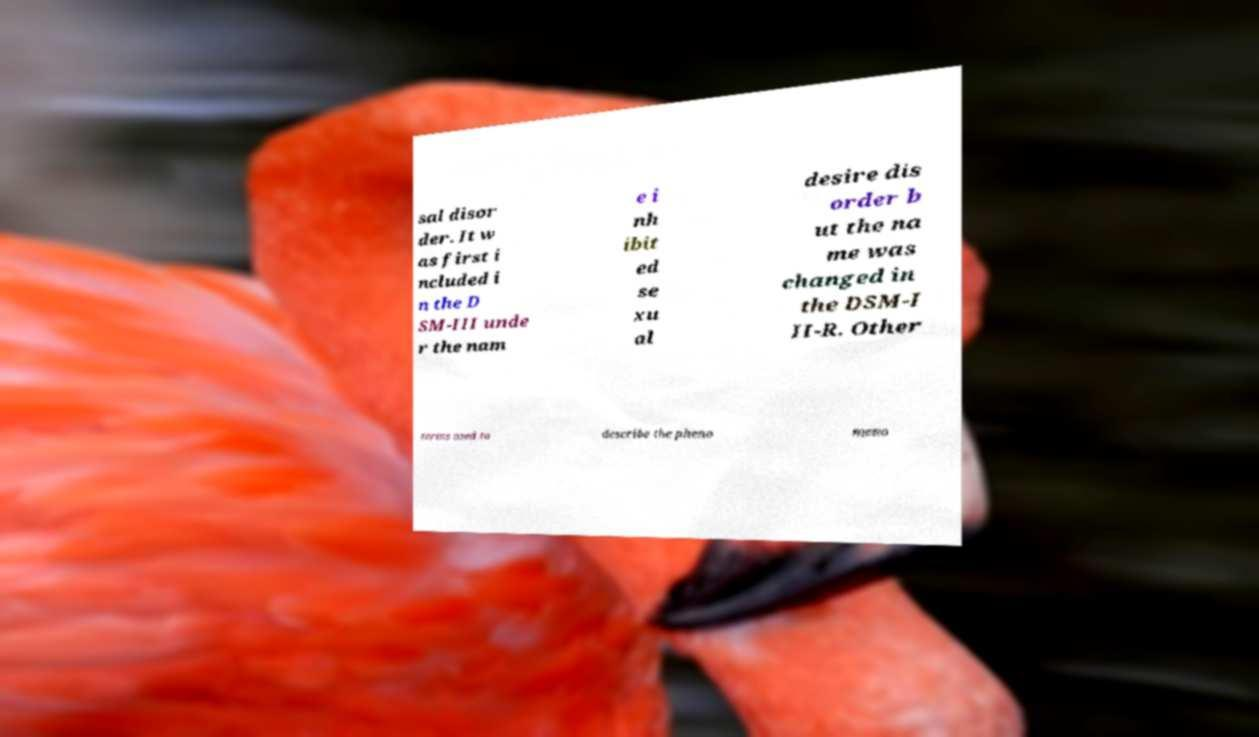Please identify and transcribe the text found in this image. sal disor der. It w as first i ncluded i n the D SM-III unde r the nam e i nh ibit ed se xu al desire dis order b ut the na me was changed in the DSM-I II-R. Other terms used to describe the pheno meno 